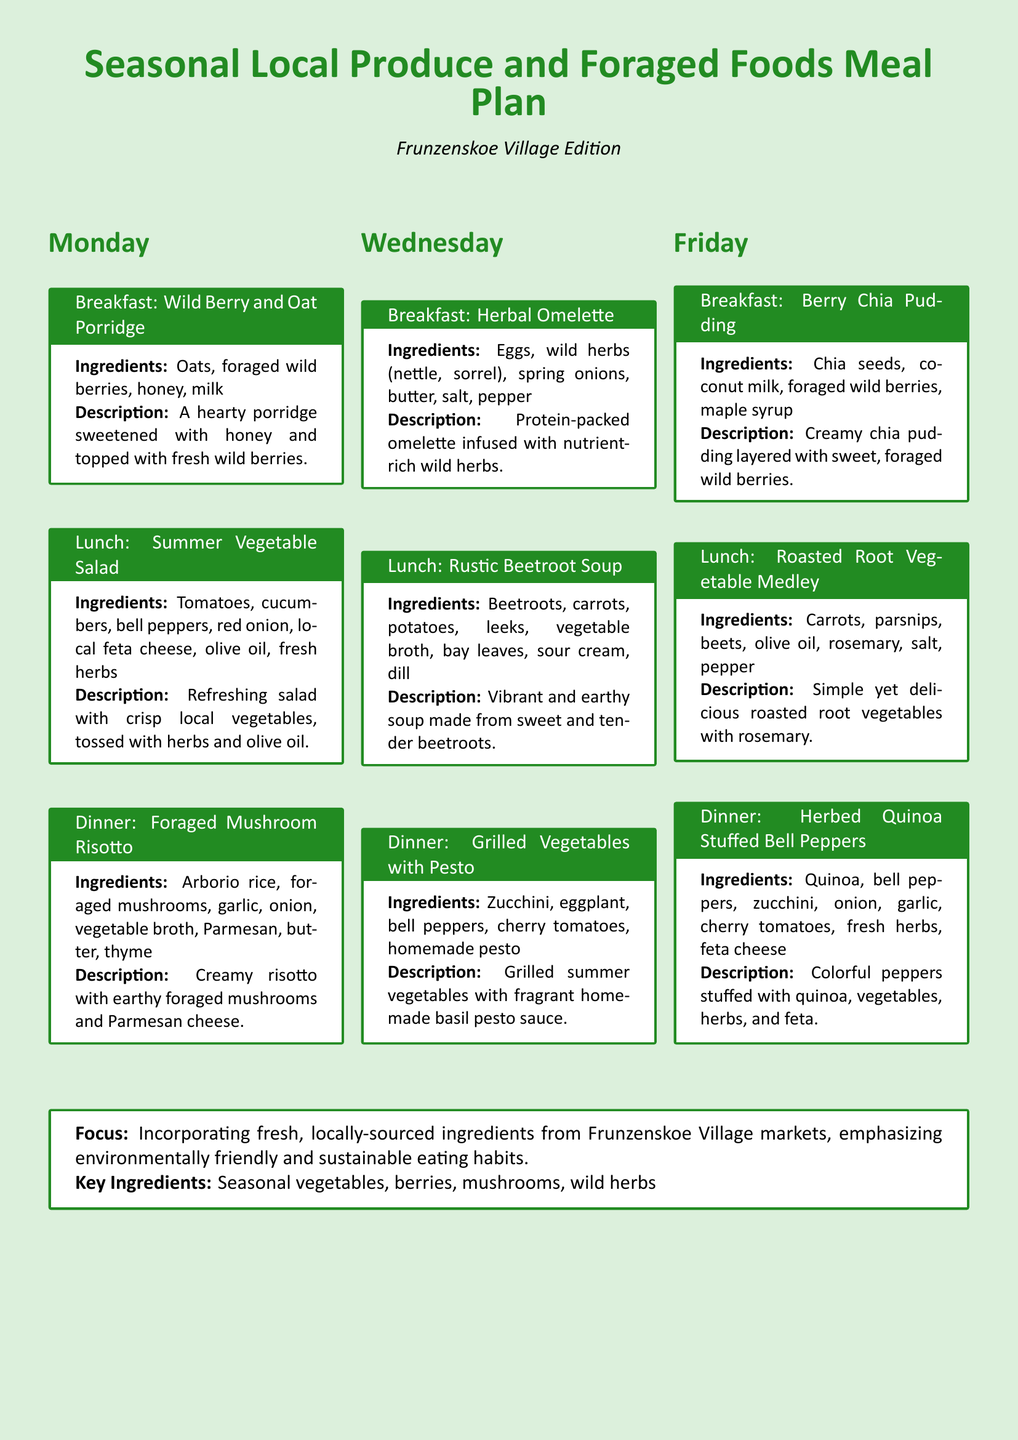what are the key ingredients featured in the meal plan? The key ingredients are specifically listed at the end of the document, mentioning seasonal vegetables, berries, mushrooms, and wild herbs.
Answer: seasonal vegetables, berries, mushrooms, wild herbs what is the breakfast dish for Monday? The document lists the breakfast option under Monday's section, which is specifically named in the meal box.
Answer: Wild Berry and Oat Porridge how many meals are suggested for each day? Each day features three meals: breakfast, lunch, and dinner, as indicated by the structure of the document.
Answer: three which day features the Grilled Vegetables with Pesto dish? The specific dish is clearly categorized under the section for Wednesday's dinner in the document.
Answer: Wednesday what type of soup is listed for Wednesday's lunch? The meal type and its ingredients are mentioned under Wednesday's lunch section.
Answer: Rustic Beetroot Soup what is the cooking method used for the root vegetables on Friday's lunch? The cooking method is indicated in the description of the dish, revealing the preparation style.
Answer: Roasted which ingredient is used in the Berry Chia Pudding? The ingredients are listed in the meal box, specifically highlighting the main components of the dish.
Answer: foraged wild berries what is the main ingredient in the Herbal Omelette? The primary ingredient is specified in the breakfast section for Wednesday.
Answer: Eggs what is emphasized in the focus section of the document? The focus section outlines the main theme of the meal plan, regarding sustainable eating practices.
Answer: environmentally friendly and sustainable eating habits 